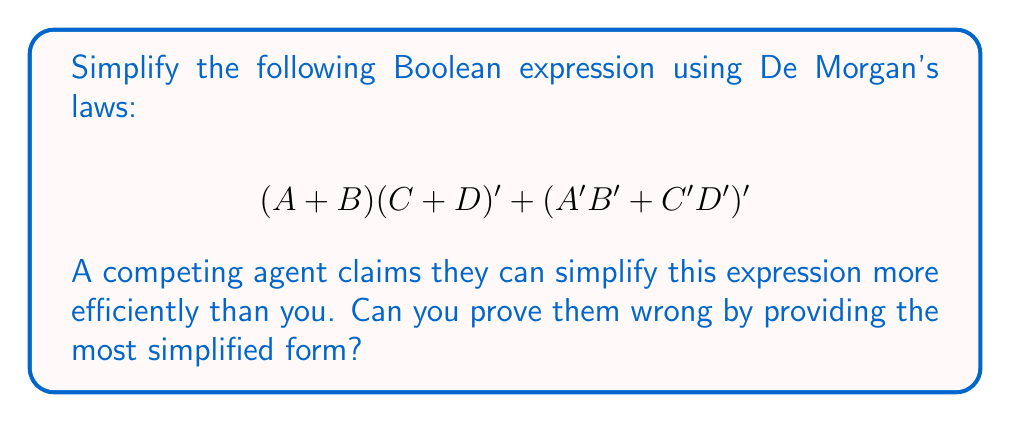Give your solution to this math problem. Let's simplify this expression step by step:

1) First, apply De Morgan's law to $(C + D)'$:
   $$(A + B)(C' \cdot D') + (A'B' + C'D')'$$

2) Now, apply the distributive property:
   $$AC' \cdot D' + BC' \cdot D' + (A'B' + C'D')'$$

3) Apply De Morgan's law to $(A'B' + C'D')'$:
   $$AC' \cdot D' + BC' \cdot D' + (A \cdot B + C \cdot D)$$

4) Distribute the last term:
   $$AC' \cdot D' + BC' \cdot D' + A \cdot B + C \cdot D$$

5) Group terms with $C'D'$:
   $$(A + B)C'D' + AB + CD$$

6) Apply the absorption law to $(A + B)C'D' + AB$:
   $$AC'D' + BC'D' + AB + CD$$

This is the most simplified form using Boolean algebra laws and De Morgan's laws.
Answer: $AC'D' + BC'D' + AB + CD$ 